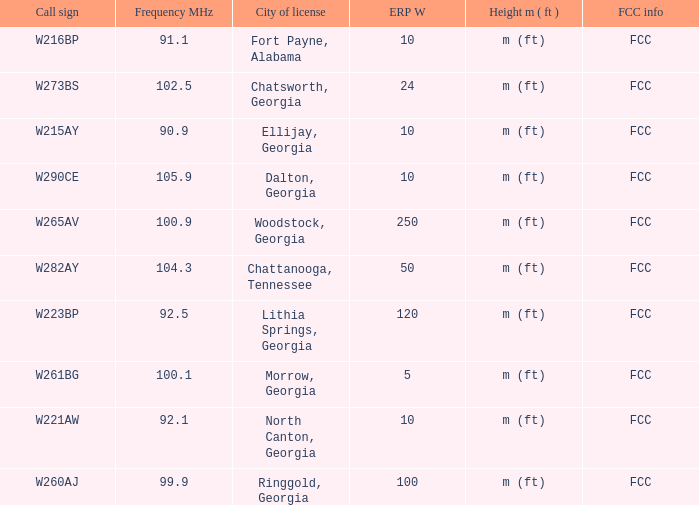How many ERP W is it that has a Call sign of w273bs? 24.0. 